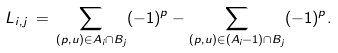<formula> <loc_0><loc_0><loc_500><loc_500>L _ { i , j } \, = \, \sum _ { ( p , u ) \in A _ { i } \cap B _ { j } } ( - 1 ) ^ { p } - \sum _ { ( p , u ) \in ( A _ { i } - 1 ) \cap B _ { j } } ( - 1 ) ^ { p } .</formula> 